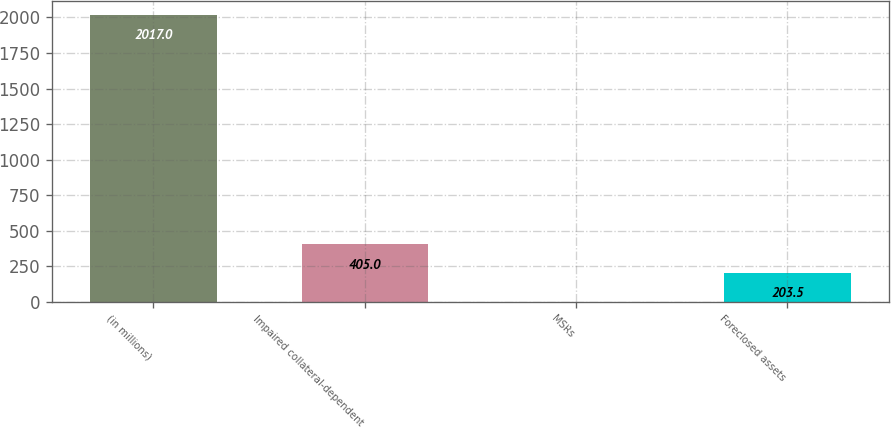Convert chart to OTSL. <chart><loc_0><loc_0><loc_500><loc_500><bar_chart><fcel>(in millions)<fcel>Impaired collateral-dependent<fcel>MSRs<fcel>Foreclosed assets<nl><fcel>2017<fcel>405<fcel>2<fcel>203.5<nl></chart> 